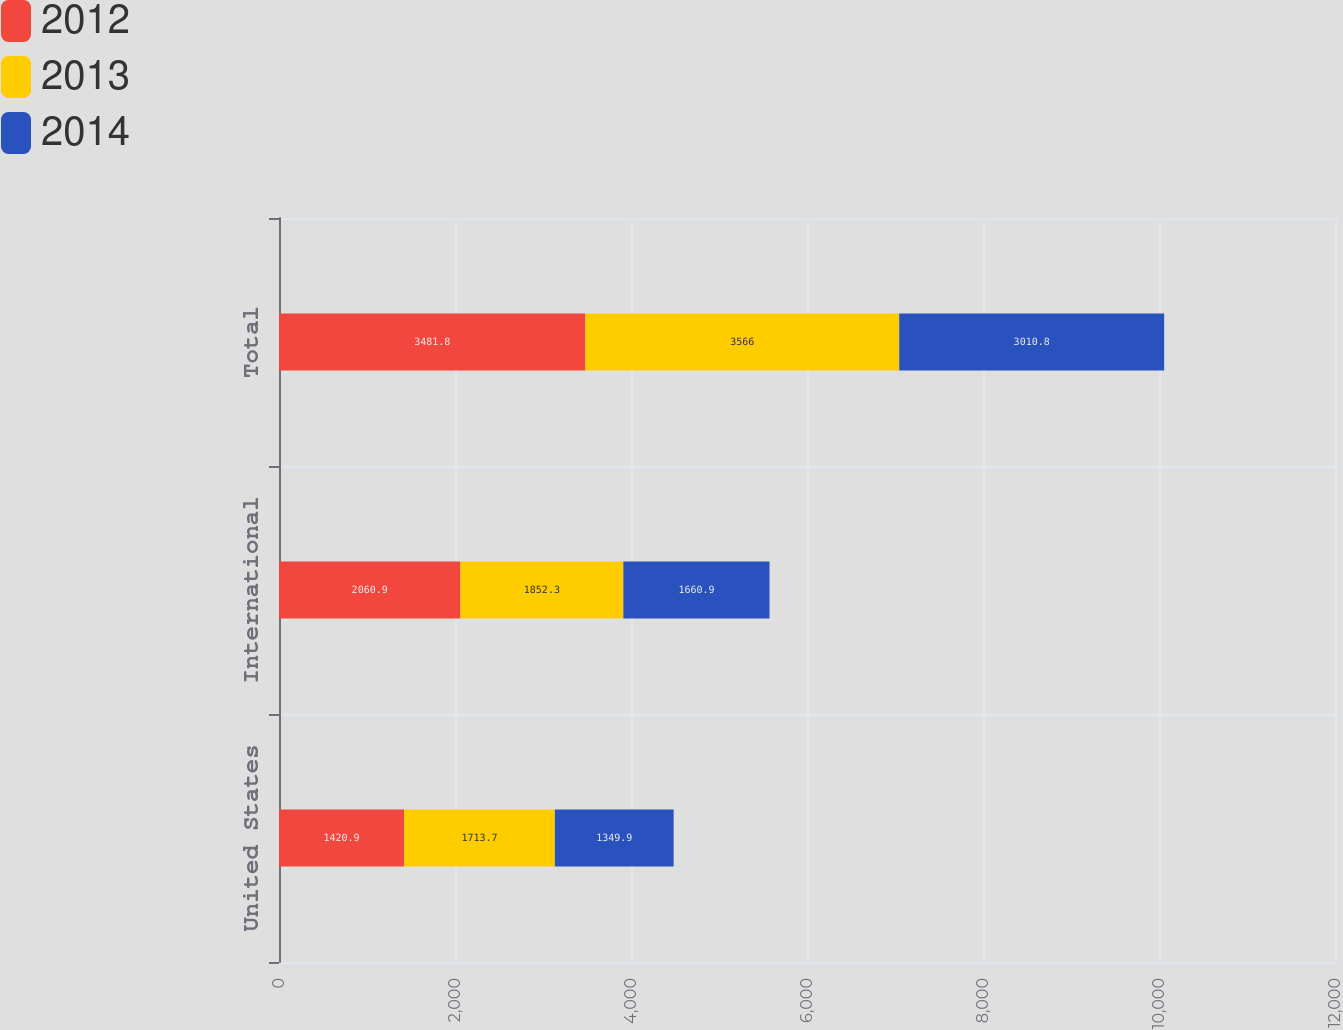<chart> <loc_0><loc_0><loc_500><loc_500><stacked_bar_chart><ecel><fcel>United States<fcel>International<fcel>Total<nl><fcel>2012<fcel>1420.9<fcel>2060.9<fcel>3481.8<nl><fcel>2013<fcel>1713.7<fcel>1852.3<fcel>3566<nl><fcel>2014<fcel>1349.9<fcel>1660.9<fcel>3010.8<nl></chart> 